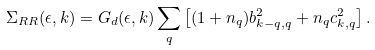Convert formula to latex. <formula><loc_0><loc_0><loc_500><loc_500>\Sigma _ { R R } ( \epsilon , { k } ) = G _ { d } ( \epsilon , { k } ) \sum _ { q } \left [ ( 1 + n _ { q } ) b ^ { 2 } _ { k - q , q } + n _ { q } c ^ { 2 } _ { k , q } \right ] .</formula> 